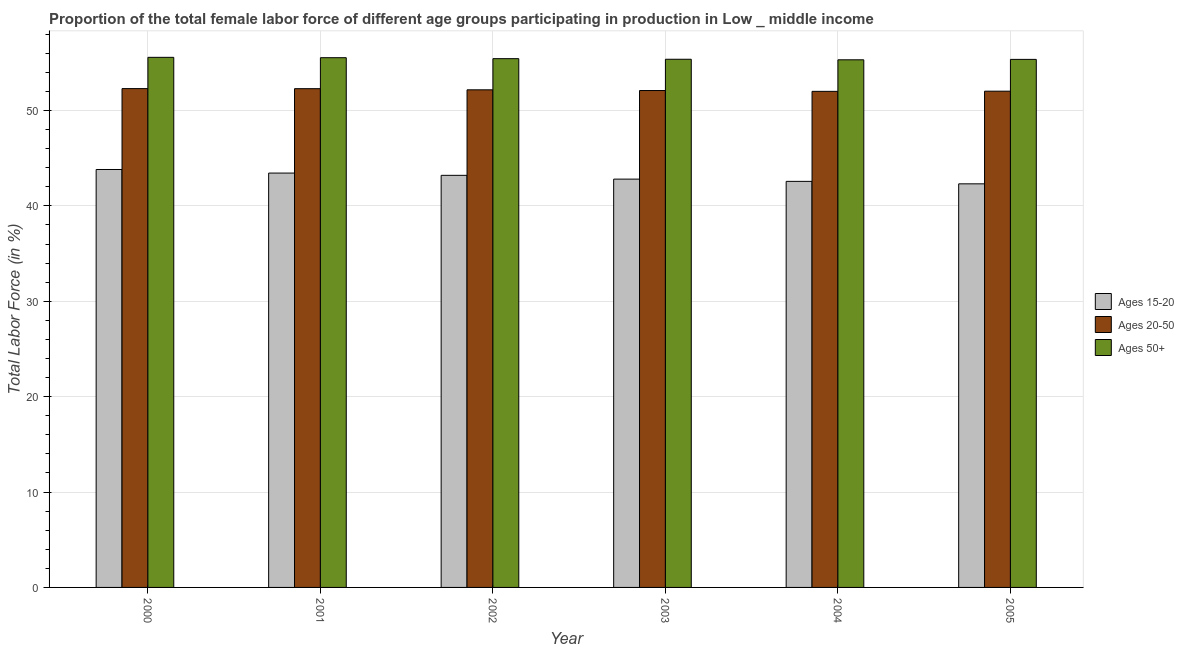Are the number of bars per tick equal to the number of legend labels?
Make the answer very short. Yes. Are the number of bars on each tick of the X-axis equal?
Ensure brevity in your answer.  Yes. How many bars are there on the 3rd tick from the right?
Your answer should be compact. 3. What is the label of the 1st group of bars from the left?
Ensure brevity in your answer.  2000. In how many cases, is the number of bars for a given year not equal to the number of legend labels?
Make the answer very short. 0. What is the percentage of female labor force within the age group 20-50 in 2004?
Make the answer very short. 52.01. Across all years, what is the maximum percentage of female labor force above age 50?
Provide a short and direct response. 55.58. Across all years, what is the minimum percentage of female labor force within the age group 15-20?
Provide a short and direct response. 42.31. In which year was the percentage of female labor force within the age group 15-20 maximum?
Make the answer very short. 2000. What is the total percentage of female labor force above age 50 in the graph?
Your answer should be very brief. 332.6. What is the difference between the percentage of female labor force within the age group 15-20 in 2002 and that in 2003?
Your answer should be compact. 0.4. What is the difference between the percentage of female labor force within the age group 20-50 in 2001 and the percentage of female labor force above age 50 in 2004?
Make the answer very short. 0.28. What is the average percentage of female labor force within the age group 20-50 per year?
Offer a very short reply. 52.15. In how many years, is the percentage of female labor force above age 50 greater than 2 %?
Ensure brevity in your answer.  6. What is the ratio of the percentage of female labor force within the age group 15-20 in 2001 to that in 2005?
Offer a terse response. 1.03. Is the percentage of female labor force above age 50 in 2004 less than that in 2005?
Provide a short and direct response. Yes. What is the difference between the highest and the second highest percentage of female labor force within the age group 15-20?
Your response must be concise. 0.38. What is the difference between the highest and the lowest percentage of female labor force above age 50?
Make the answer very short. 0.26. Is the sum of the percentage of female labor force above age 50 in 2000 and 2003 greater than the maximum percentage of female labor force within the age group 20-50 across all years?
Keep it short and to the point. Yes. What does the 3rd bar from the left in 2004 represents?
Ensure brevity in your answer.  Ages 50+. What does the 3rd bar from the right in 2000 represents?
Offer a terse response. Ages 15-20. Is it the case that in every year, the sum of the percentage of female labor force within the age group 15-20 and percentage of female labor force within the age group 20-50 is greater than the percentage of female labor force above age 50?
Keep it short and to the point. Yes. How many bars are there?
Your answer should be compact. 18. Are all the bars in the graph horizontal?
Your answer should be compact. No. Are the values on the major ticks of Y-axis written in scientific E-notation?
Ensure brevity in your answer.  No. Does the graph contain any zero values?
Your answer should be very brief. No. Does the graph contain grids?
Provide a short and direct response. Yes. What is the title of the graph?
Make the answer very short. Proportion of the total female labor force of different age groups participating in production in Low _ middle income. Does "Oil" appear as one of the legend labels in the graph?
Provide a short and direct response. No. What is the label or title of the X-axis?
Provide a short and direct response. Year. What is the label or title of the Y-axis?
Provide a succinct answer. Total Labor Force (in %). What is the Total Labor Force (in %) of Ages 15-20 in 2000?
Your response must be concise. 43.82. What is the Total Labor Force (in %) in Ages 20-50 in 2000?
Offer a very short reply. 52.3. What is the Total Labor Force (in %) of Ages 50+ in 2000?
Provide a short and direct response. 55.58. What is the Total Labor Force (in %) in Ages 15-20 in 2001?
Offer a very short reply. 43.44. What is the Total Labor Force (in %) in Ages 20-50 in 2001?
Your answer should be very brief. 52.29. What is the Total Labor Force (in %) of Ages 50+ in 2001?
Keep it short and to the point. 55.54. What is the Total Labor Force (in %) of Ages 15-20 in 2002?
Offer a terse response. 43.2. What is the Total Labor Force (in %) of Ages 20-50 in 2002?
Provide a succinct answer. 52.17. What is the Total Labor Force (in %) in Ages 50+ in 2002?
Provide a short and direct response. 55.44. What is the Total Labor Force (in %) in Ages 15-20 in 2003?
Ensure brevity in your answer.  42.81. What is the Total Labor Force (in %) in Ages 20-50 in 2003?
Give a very brief answer. 52.09. What is the Total Labor Force (in %) in Ages 50+ in 2003?
Your answer should be very brief. 55.37. What is the Total Labor Force (in %) in Ages 15-20 in 2004?
Ensure brevity in your answer.  42.57. What is the Total Labor Force (in %) of Ages 20-50 in 2004?
Your answer should be compact. 52.01. What is the Total Labor Force (in %) in Ages 50+ in 2004?
Your response must be concise. 55.32. What is the Total Labor Force (in %) of Ages 15-20 in 2005?
Make the answer very short. 42.31. What is the Total Labor Force (in %) in Ages 20-50 in 2005?
Make the answer very short. 52.03. What is the Total Labor Force (in %) of Ages 50+ in 2005?
Make the answer very short. 55.36. Across all years, what is the maximum Total Labor Force (in %) in Ages 15-20?
Provide a succinct answer. 43.82. Across all years, what is the maximum Total Labor Force (in %) in Ages 20-50?
Your response must be concise. 52.3. Across all years, what is the maximum Total Labor Force (in %) in Ages 50+?
Your answer should be very brief. 55.58. Across all years, what is the minimum Total Labor Force (in %) in Ages 15-20?
Give a very brief answer. 42.31. Across all years, what is the minimum Total Labor Force (in %) in Ages 20-50?
Offer a very short reply. 52.01. Across all years, what is the minimum Total Labor Force (in %) in Ages 50+?
Provide a succinct answer. 55.32. What is the total Total Labor Force (in %) in Ages 15-20 in the graph?
Your answer should be very brief. 258.16. What is the total Total Labor Force (in %) in Ages 20-50 in the graph?
Offer a terse response. 312.89. What is the total Total Labor Force (in %) of Ages 50+ in the graph?
Your answer should be compact. 332.6. What is the difference between the Total Labor Force (in %) in Ages 15-20 in 2000 and that in 2001?
Keep it short and to the point. 0.38. What is the difference between the Total Labor Force (in %) in Ages 20-50 in 2000 and that in 2001?
Your response must be concise. 0.01. What is the difference between the Total Labor Force (in %) of Ages 50+ in 2000 and that in 2001?
Your answer should be compact. 0.04. What is the difference between the Total Labor Force (in %) in Ages 15-20 in 2000 and that in 2002?
Keep it short and to the point. 0.61. What is the difference between the Total Labor Force (in %) of Ages 20-50 in 2000 and that in 2002?
Offer a terse response. 0.13. What is the difference between the Total Labor Force (in %) in Ages 50+ in 2000 and that in 2002?
Your response must be concise. 0.14. What is the difference between the Total Labor Force (in %) in Ages 20-50 in 2000 and that in 2003?
Provide a short and direct response. 0.2. What is the difference between the Total Labor Force (in %) of Ages 50+ in 2000 and that in 2003?
Give a very brief answer. 0.2. What is the difference between the Total Labor Force (in %) of Ages 15-20 in 2000 and that in 2004?
Provide a succinct answer. 1.24. What is the difference between the Total Labor Force (in %) in Ages 20-50 in 2000 and that in 2004?
Provide a succinct answer. 0.29. What is the difference between the Total Labor Force (in %) in Ages 50+ in 2000 and that in 2004?
Offer a terse response. 0.26. What is the difference between the Total Labor Force (in %) of Ages 15-20 in 2000 and that in 2005?
Offer a terse response. 1.5. What is the difference between the Total Labor Force (in %) in Ages 20-50 in 2000 and that in 2005?
Offer a terse response. 0.27. What is the difference between the Total Labor Force (in %) in Ages 50+ in 2000 and that in 2005?
Ensure brevity in your answer.  0.22. What is the difference between the Total Labor Force (in %) of Ages 15-20 in 2001 and that in 2002?
Your answer should be very brief. 0.24. What is the difference between the Total Labor Force (in %) of Ages 20-50 in 2001 and that in 2002?
Make the answer very short. 0.12. What is the difference between the Total Labor Force (in %) of Ages 50+ in 2001 and that in 2002?
Your answer should be very brief. 0.1. What is the difference between the Total Labor Force (in %) of Ages 15-20 in 2001 and that in 2003?
Your response must be concise. 0.63. What is the difference between the Total Labor Force (in %) in Ages 20-50 in 2001 and that in 2003?
Your response must be concise. 0.2. What is the difference between the Total Labor Force (in %) of Ages 50+ in 2001 and that in 2003?
Your answer should be compact. 0.16. What is the difference between the Total Labor Force (in %) in Ages 15-20 in 2001 and that in 2004?
Ensure brevity in your answer.  0.87. What is the difference between the Total Labor Force (in %) in Ages 20-50 in 2001 and that in 2004?
Make the answer very short. 0.28. What is the difference between the Total Labor Force (in %) of Ages 50+ in 2001 and that in 2004?
Provide a short and direct response. 0.22. What is the difference between the Total Labor Force (in %) in Ages 15-20 in 2001 and that in 2005?
Give a very brief answer. 1.13. What is the difference between the Total Labor Force (in %) in Ages 20-50 in 2001 and that in 2005?
Give a very brief answer. 0.26. What is the difference between the Total Labor Force (in %) of Ages 50+ in 2001 and that in 2005?
Make the answer very short. 0.18. What is the difference between the Total Labor Force (in %) of Ages 15-20 in 2002 and that in 2003?
Your answer should be compact. 0.4. What is the difference between the Total Labor Force (in %) in Ages 20-50 in 2002 and that in 2003?
Give a very brief answer. 0.08. What is the difference between the Total Labor Force (in %) in Ages 50+ in 2002 and that in 2003?
Provide a succinct answer. 0.06. What is the difference between the Total Labor Force (in %) of Ages 15-20 in 2002 and that in 2004?
Keep it short and to the point. 0.63. What is the difference between the Total Labor Force (in %) of Ages 20-50 in 2002 and that in 2004?
Provide a succinct answer. 0.16. What is the difference between the Total Labor Force (in %) in Ages 50+ in 2002 and that in 2004?
Make the answer very short. 0.12. What is the difference between the Total Labor Force (in %) of Ages 15-20 in 2002 and that in 2005?
Your answer should be compact. 0.89. What is the difference between the Total Labor Force (in %) in Ages 20-50 in 2002 and that in 2005?
Ensure brevity in your answer.  0.14. What is the difference between the Total Labor Force (in %) in Ages 50+ in 2002 and that in 2005?
Make the answer very short. 0.07. What is the difference between the Total Labor Force (in %) of Ages 15-20 in 2003 and that in 2004?
Provide a short and direct response. 0.23. What is the difference between the Total Labor Force (in %) in Ages 20-50 in 2003 and that in 2004?
Ensure brevity in your answer.  0.08. What is the difference between the Total Labor Force (in %) of Ages 50+ in 2003 and that in 2004?
Provide a succinct answer. 0.06. What is the difference between the Total Labor Force (in %) in Ages 15-20 in 2003 and that in 2005?
Offer a terse response. 0.49. What is the difference between the Total Labor Force (in %) of Ages 20-50 in 2003 and that in 2005?
Offer a very short reply. 0.07. What is the difference between the Total Labor Force (in %) of Ages 50+ in 2003 and that in 2005?
Keep it short and to the point. 0.01. What is the difference between the Total Labor Force (in %) of Ages 15-20 in 2004 and that in 2005?
Your answer should be compact. 0.26. What is the difference between the Total Labor Force (in %) of Ages 20-50 in 2004 and that in 2005?
Your answer should be compact. -0.02. What is the difference between the Total Labor Force (in %) in Ages 50+ in 2004 and that in 2005?
Your response must be concise. -0.04. What is the difference between the Total Labor Force (in %) of Ages 15-20 in 2000 and the Total Labor Force (in %) of Ages 20-50 in 2001?
Provide a short and direct response. -8.47. What is the difference between the Total Labor Force (in %) of Ages 15-20 in 2000 and the Total Labor Force (in %) of Ages 50+ in 2001?
Ensure brevity in your answer.  -11.72. What is the difference between the Total Labor Force (in %) in Ages 20-50 in 2000 and the Total Labor Force (in %) in Ages 50+ in 2001?
Give a very brief answer. -3.24. What is the difference between the Total Labor Force (in %) in Ages 15-20 in 2000 and the Total Labor Force (in %) in Ages 20-50 in 2002?
Offer a terse response. -8.35. What is the difference between the Total Labor Force (in %) of Ages 15-20 in 2000 and the Total Labor Force (in %) of Ages 50+ in 2002?
Keep it short and to the point. -11.62. What is the difference between the Total Labor Force (in %) in Ages 20-50 in 2000 and the Total Labor Force (in %) in Ages 50+ in 2002?
Make the answer very short. -3.14. What is the difference between the Total Labor Force (in %) in Ages 15-20 in 2000 and the Total Labor Force (in %) in Ages 20-50 in 2003?
Make the answer very short. -8.28. What is the difference between the Total Labor Force (in %) of Ages 15-20 in 2000 and the Total Labor Force (in %) of Ages 50+ in 2003?
Offer a terse response. -11.56. What is the difference between the Total Labor Force (in %) in Ages 20-50 in 2000 and the Total Labor Force (in %) in Ages 50+ in 2003?
Keep it short and to the point. -3.08. What is the difference between the Total Labor Force (in %) in Ages 15-20 in 2000 and the Total Labor Force (in %) in Ages 20-50 in 2004?
Your answer should be compact. -8.19. What is the difference between the Total Labor Force (in %) of Ages 15-20 in 2000 and the Total Labor Force (in %) of Ages 50+ in 2004?
Provide a succinct answer. -11.5. What is the difference between the Total Labor Force (in %) in Ages 20-50 in 2000 and the Total Labor Force (in %) in Ages 50+ in 2004?
Your answer should be very brief. -3.02. What is the difference between the Total Labor Force (in %) of Ages 15-20 in 2000 and the Total Labor Force (in %) of Ages 20-50 in 2005?
Your answer should be very brief. -8.21. What is the difference between the Total Labor Force (in %) in Ages 15-20 in 2000 and the Total Labor Force (in %) in Ages 50+ in 2005?
Keep it short and to the point. -11.54. What is the difference between the Total Labor Force (in %) of Ages 20-50 in 2000 and the Total Labor Force (in %) of Ages 50+ in 2005?
Keep it short and to the point. -3.06. What is the difference between the Total Labor Force (in %) of Ages 15-20 in 2001 and the Total Labor Force (in %) of Ages 20-50 in 2002?
Offer a very short reply. -8.73. What is the difference between the Total Labor Force (in %) of Ages 15-20 in 2001 and the Total Labor Force (in %) of Ages 50+ in 2002?
Make the answer very short. -11.99. What is the difference between the Total Labor Force (in %) of Ages 20-50 in 2001 and the Total Labor Force (in %) of Ages 50+ in 2002?
Your answer should be very brief. -3.15. What is the difference between the Total Labor Force (in %) in Ages 15-20 in 2001 and the Total Labor Force (in %) in Ages 20-50 in 2003?
Ensure brevity in your answer.  -8.65. What is the difference between the Total Labor Force (in %) of Ages 15-20 in 2001 and the Total Labor Force (in %) of Ages 50+ in 2003?
Provide a short and direct response. -11.93. What is the difference between the Total Labor Force (in %) of Ages 20-50 in 2001 and the Total Labor Force (in %) of Ages 50+ in 2003?
Provide a succinct answer. -3.08. What is the difference between the Total Labor Force (in %) of Ages 15-20 in 2001 and the Total Labor Force (in %) of Ages 20-50 in 2004?
Offer a terse response. -8.57. What is the difference between the Total Labor Force (in %) of Ages 15-20 in 2001 and the Total Labor Force (in %) of Ages 50+ in 2004?
Provide a succinct answer. -11.87. What is the difference between the Total Labor Force (in %) of Ages 20-50 in 2001 and the Total Labor Force (in %) of Ages 50+ in 2004?
Offer a very short reply. -3.03. What is the difference between the Total Labor Force (in %) of Ages 15-20 in 2001 and the Total Labor Force (in %) of Ages 20-50 in 2005?
Provide a succinct answer. -8.59. What is the difference between the Total Labor Force (in %) in Ages 15-20 in 2001 and the Total Labor Force (in %) in Ages 50+ in 2005?
Provide a succinct answer. -11.92. What is the difference between the Total Labor Force (in %) of Ages 20-50 in 2001 and the Total Labor Force (in %) of Ages 50+ in 2005?
Make the answer very short. -3.07. What is the difference between the Total Labor Force (in %) in Ages 15-20 in 2002 and the Total Labor Force (in %) in Ages 20-50 in 2003?
Your response must be concise. -8.89. What is the difference between the Total Labor Force (in %) of Ages 15-20 in 2002 and the Total Labor Force (in %) of Ages 50+ in 2003?
Keep it short and to the point. -12.17. What is the difference between the Total Labor Force (in %) of Ages 20-50 in 2002 and the Total Labor Force (in %) of Ages 50+ in 2003?
Your answer should be very brief. -3.2. What is the difference between the Total Labor Force (in %) in Ages 15-20 in 2002 and the Total Labor Force (in %) in Ages 20-50 in 2004?
Offer a terse response. -8.81. What is the difference between the Total Labor Force (in %) of Ages 15-20 in 2002 and the Total Labor Force (in %) of Ages 50+ in 2004?
Make the answer very short. -12.11. What is the difference between the Total Labor Force (in %) in Ages 20-50 in 2002 and the Total Labor Force (in %) in Ages 50+ in 2004?
Provide a succinct answer. -3.15. What is the difference between the Total Labor Force (in %) of Ages 15-20 in 2002 and the Total Labor Force (in %) of Ages 20-50 in 2005?
Make the answer very short. -8.82. What is the difference between the Total Labor Force (in %) of Ages 15-20 in 2002 and the Total Labor Force (in %) of Ages 50+ in 2005?
Ensure brevity in your answer.  -12.16. What is the difference between the Total Labor Force (in %) in Ages 20-50 in 2002 and the Total Labor Force (in %) in Ages 50+ in 2005?
Provide a succinct answer. -3.19. What is the difference between the Total Labor Force (in %) in Ages 15-20 in 2003 and the Total Labor Force (in %) in Ages 20-50 in 2004?
Your answer should be compact. -9.2. What is the difference between the Total Labor Force (in %) in Ages 15-20 in 2003 and the Total Labor Force (in %) in Ages 50+ in 2004?
Your response must be concise. -12.51. What is the difference between the Total Labor Force (in %) in Ages 20-50 in 2003 and the Total Labor Force (in %) in Ages 50+ in 2004?
Offer a terse response. -3.22. What is the difference between the Total Labor Force (in %) of Ages 15-20 in 2003 and the Total Labor Force (in %) of Ages 20-50 in 2005?
Your answer should be compact. -9.22. What is the difference between the Total Labor Force (in %) of Ages 15-20 in 2003 and the Total Labor Force (in %) of Ages 50+ in 2005?
Give a very brief answer. -12.55. What is the difference between the Total Labor Force (in %) of Ages 20-50 in 2003 and the Total Labor Force (in %) of Ages 50+ in 2005?
Make the answer very short. -3.27. What is the difference between the Total Labor Force (in %) of Ages 15-20 in 2004 and the Total Labor Force (in %) of Ages 20-50 in 2005?
Provide a succinct answer. -9.46. What is the difference between the Total Labor Force (in %) in Ages 15-20 in 2004 and the Total Labor Force (in %) in Ages 50+ in 2005?
Offer a very short reply. -12.79. What is the difference between the Total Labor Force (in %) in Ages 20-50 in 2004 and the Total Labor Force (in %) in Ages 50+ in 2005?
Keep it short and to the point. -3.35. What is the average Total Labor Force (in %) in Ages 15-20 per year?
Make the answer very short. 43.03. What is the average Total Labor Force (in %) in Ages 20-50 per year?
Provide a succinct answer. 52.15. What is the average Total Labor Force (in %) of Ages 50+ per year?
Provide a short and direct response. 55.43. In the year 2000, what is the difference between the Total Labor Force (in %) of Ages 15-20 and Total Labor Force (in %) of Ages 20-50?
Keep it short and to the point. -8.48. In the year 2000, what is the difference between the Total Labor Force (in %) of Ages 15-20 and Total Labor Force (in %) of Ages 50+?
Give a very brief answer. -11.76. In the year 2000, what is the difference between the Total Labor Force (in %) in Ages 20-50 and Total Labor Force (in %) in Ages 50+?
Provide a short and direct response. -3.28. In the year 2001, what is the difference between the Total Labor Force (in %) of Ages 15-20 and Total Labor Force (in %) of Ages 20-50?
Your response must be concise. -8.85. In the year 2001, what is the difference between the Total Labor Force (in %) of Ages 15-20 and Total Labor Force (in %) of Ages 50+?
Give a very brief answer. -12.1. In the year 2001, what is the difference between the Total Labor Force (in %) of Ages 20-50 and Total Labor Force (in %) of Ages 50+?
Provide a succinct answer. -3.25. In the year 2002, what is the difference between the Total Labor Force (in %) of Ages 15-20 and Total Labor Force (in %) of Ages 20-50?
Your response must be concise. -8.97. In the year 2002, what is the difference between the Total Labor Force (in %) in Ages 15-20 and Total Labor Force (in %) in Ages 50+?
Ensure brevity in your answer.  -12.23. In the year 2002, what is the difference between the Total Labor Force (in %) of Ages 20-50 and Total Labor Force (in %) of Ages 50+?
Provide a short and direct response. -3.27. In the year 2003, what is the difference between the Total Labor Force (in %) in Ages 15-20 and Total Labor Force (in %) in Ages 20-50?
Ensure brevity in your answer.  -9.29. In the year 2003, what is the difference between the Total Labor Force (in %) of Ages 15-20 and Total Labor Force (in %) of Ages 50+?
Give a very brief answer. -12.57. In the year 2003, what is the difference between the Total Labor Force (in %) in Ages 20-50 and Total Labor Force (in %) in Ages 50+?
Make the answer very short. -3.28. In the year 2004, what is the difference between the Total Labor Force (in %) of Ages 15-20 and Total Labor Force (in %) of Ages 20-50?
Ensure brevity in your answer.  -9.44. In the year 2004, what is the difference between the Total Labor Force (in %) of Ages 15-20 and Total Labor Force (in %) of Ages 50+?
Your answer should be compact. -12.74. In the year 2004, what is the difference between the Total Labor Force (in %) of Ages 20-50 and Total Labor Force (in %) of Ages 50+?
Provide a short and direct response. -3.31. In the year 2005, what is the difference between the Total Labor Force (in %) of Ages 15-20 and Total Labor Force (in %) of Ages 20-50?
Provide a short and direct response. -9.71. In the year 2005, what is the difference between the Total Labor Force (in %) in Ages 15-20 and Total Labor Force (in %) in Ages 50+?
Ensure brevity in your answer.  -13.05. In the year 2005, what is the difference between the Total Labor Force (in %) of Ages 20-50 and Total Labor Force (in %) of Ages 50+?
Provide a short and direct response. -3.33. What is the ratio of the Total Labor Force (in %) of Ages 15-20 in 2000 to that in 2001?
Keep it short and to the point. 1.01. What is the ratio of the Total Labor Force (in %) in Ages 15-20 in 2000 to that in 2002?
Provide a short and direct response. 1.01. What is the ratio of the Total Labor Force (in %) of Ages 20-50 in 2000 to that in 2002?
Offer a very short reply. 1. What is the ratio of the Total Labor Force (in %) in Ages 50+ in 2000 to that in 2002?
Your answer should be compact. 1. What is the ratio of the Total Labor Force (in %) of Ages 15-20 in 2000 to that in 2003?
Offer a very short reply. 1.02. What is the ratio of the Total Labor Force (in %) in Ages 50+ in 2000 to that in 2003?
Your answer should be compact. 1. What is the ratio of the Total Labor Force (in %) in Ages 15-20 in 2000 to that in 2004?
Your response must be concise. 1.03. What is the ratio of the Total Labor Force (in %) of Ages 15-20 in 2000 to that in 2005?
Your answer should be very brief. 1.04. What is the ratio of the Total Labor Force (in %) of Ages 20-50 in 2000 to that in 2005?
Ensure brevity in your answer.  1.01. What is the ratio of the Total Labor Force (in %) in Ages 50+ in 2000 to that in 2005?
Keep it short and to the point. 1. What is the ratio of the Total Labor Force (in %) in Ages 15-20 in 2001 to that in 2002?
Offer a terse response. 1.01. What is the ratio of the Total Labor Force (in %) of Ages 15-20 in 2001 to that in 2003?
Offer a very short reply. 1.01. What is the ratio of the Total Labor Force (in %) of Ages 20-50 in 2001 to that in 2003?
Provide a short and direct response. 1. What is the ratio of the Total Labor Force (in %) of Ages 15-20 in 2001 to that in 2004?
Offer a terse response. 1.02. What is the ratio of the Total Labor Force (in %) in Ages 20-50 in 2001 to that in 2004?
Provide a short and direct response. 1.01. What is the ratio of the Total Labor Force (in %) of Ages 15-20 in 2001 to that in 2005?
Make the answer very short. 1.03. What is the ratio of the Total Labor Force (in %) in Ages 15-20 in 2002 to that in 2003?
Your answer should be compact. 1.01. What is the ratio of the Total Labor Force (in %) of Ages 20-50 in 2002 to that in 2003?
Your response must be concise. 1. What is the ratio of the Total Labor Force (in %) in Ages 15-20 in 2002 to that in 2004?
Make the answer very short. 1.01. What is the ratio of the Total Labor Force (in %) of Ages 20-50 in 2002 to that in 2004?
Provide a short and direct response. 1. What is the ratio of the Total Labor Force (in %) in Ages 15-20 in 2002 to that in 2005?
Make the answer very short. 1.02. What is the ratio of the Total Labor Force (in %) in Ages 20-50 in 2002 to that in 2005?
Offer a very short reply. 1. What is the ratio of the Total Labor Force (in %) in Ages 50+ in 2002 to that in 2005?
Your response must be concise. 1. What is the ratio of the Total Labor Force (in %) in Ages 15-20 in 2003 to that in 2004?
Keep it short and to the point. 1.01. What is the ratio of the Total Labor Force (in %) in Ages 15-20 in 2003 to that in 2005?
Offer a terse response. 1.01. What is the ratio of the Total Labor Force (in %) in Ages 20-50 in 2003 to that in 2005?
Provide a short and direct response. 1. What is the ratio of the Total Labor Force (in %) in Ages 20-50 in 2004 to that in 2005?
Offer a terse response. 1. What is the ratio of the Total Labor Force (in %) of Ages 50+ in 2004 to that in 2005?
Your answer should be compact. 1. What is the difference between the highest and the second highest Total Labor Force (in %) in Ages 15-20?
Offer a terse response. 0.38. What is the difference between the highest and the second highest Total Labor Force (in %) in Ages 20-50?
Provide a short and direct response. 0.01. What is the difference between the highest and the second highest Total Labor Force (in %) of Ages 50+?
Provide a short and direct response. 0.04. What is the difference between the highest and the lowest Total Labor Force (in %) in Ages 15-20?
Your answer should be very brief. 1.5. What is the difference between the highest and the lowest Total Labor Force (in %) in Ages 20-50?
Keep it short and to the point. 0.29. What is the difference between the highest and the lowest Total Labor Force (in %) of Ages 50+?
Make the answer very short. 0.26. 